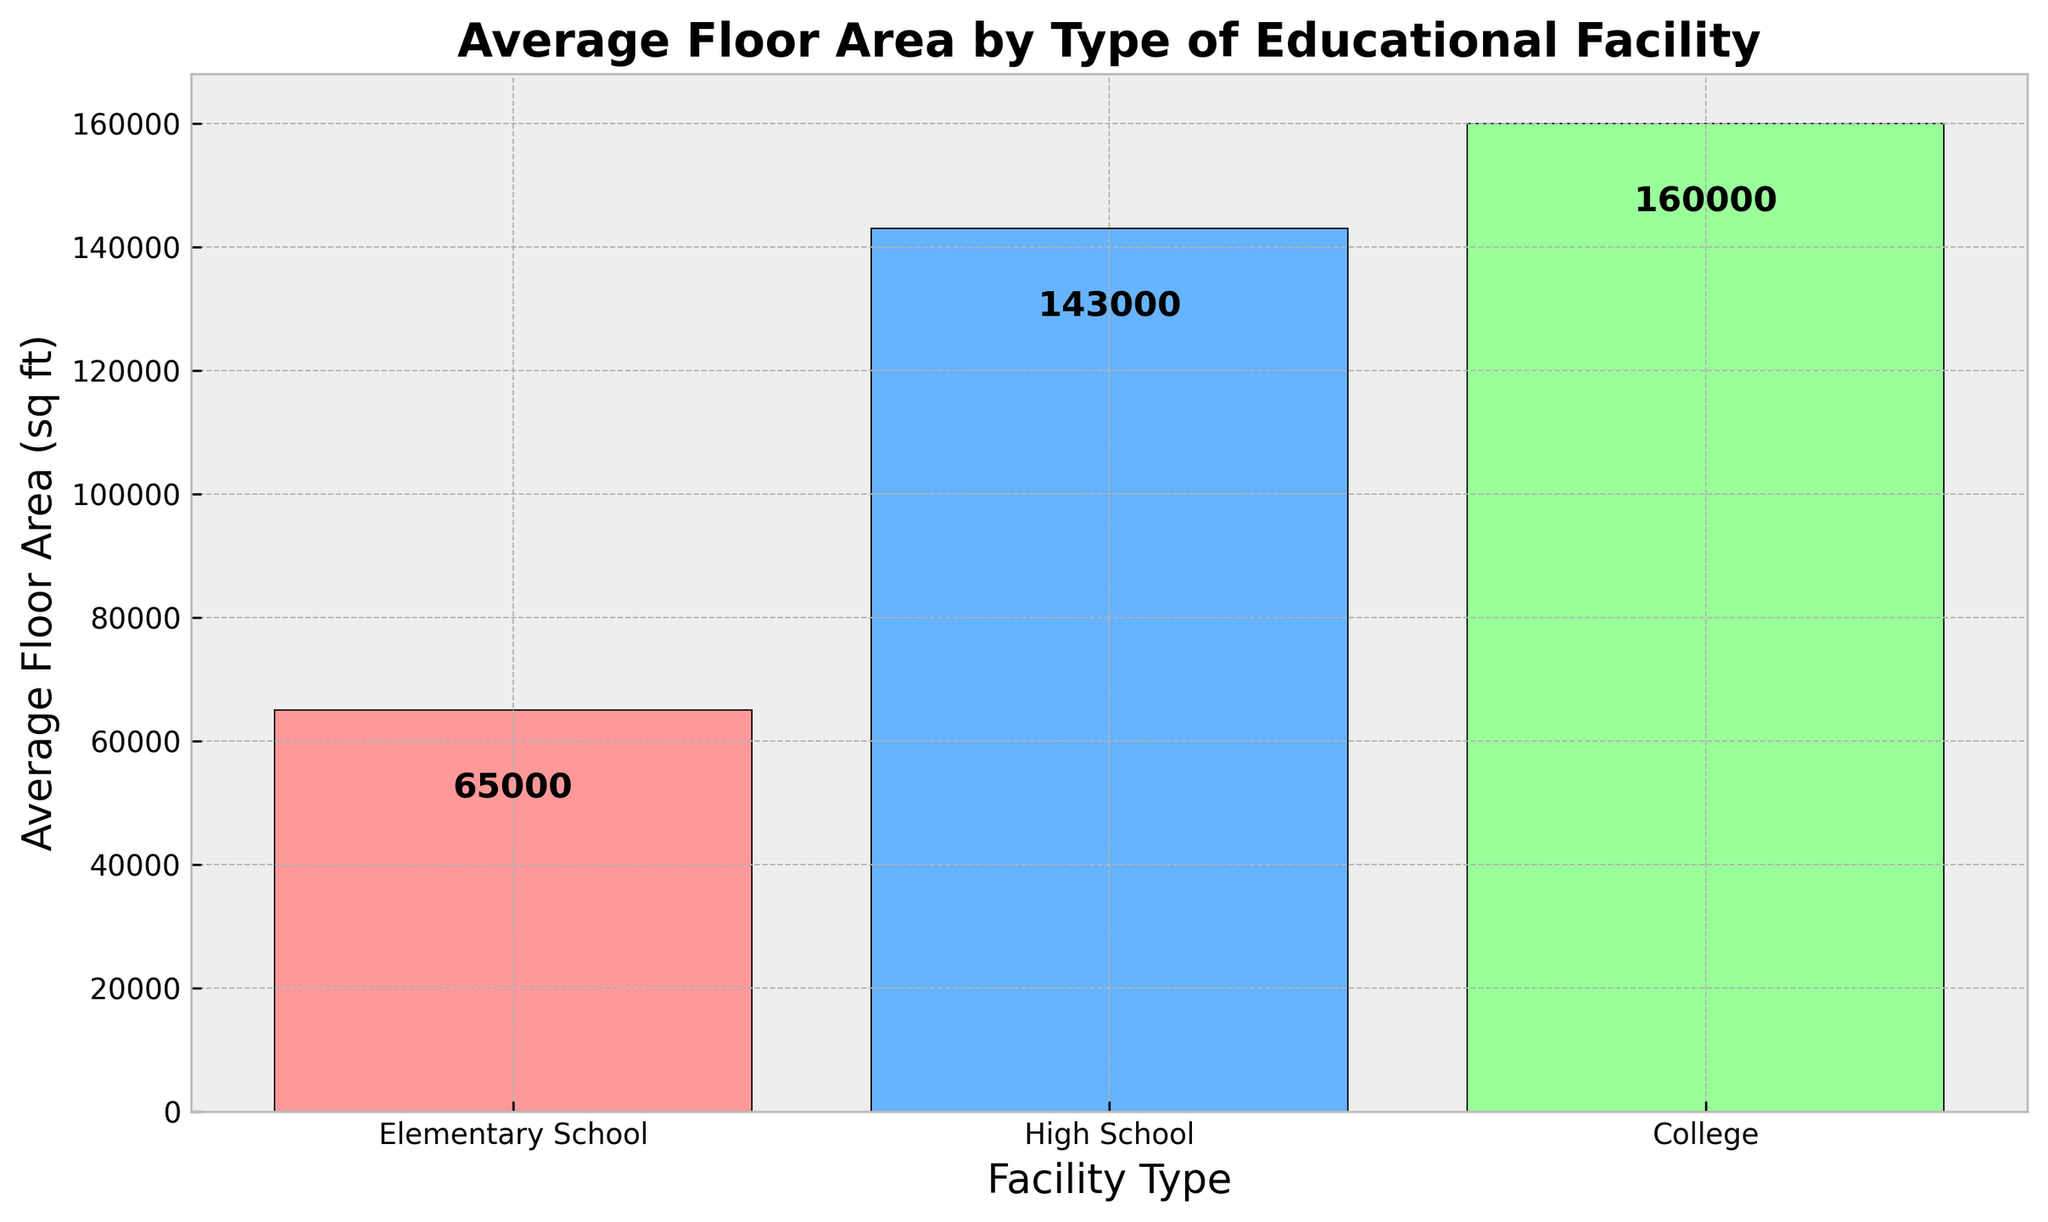Which facility type has the largest average floor area? According to the chart, among Elementary School, High School, and College, the bar representing College is the tallest, indicating that College has the largest average floor area.
Answer: College What is the difference in average floor area between High School and Elementary School? The average floor area for High School is 143,000 sq ft and for Elementary School is 65,000 sq ft. The difference is calculated as 143,000 - 65,000 = 78,000 sq ft.
Answer: 78,000 sq ft Compare the average floor area of Elementary School and College. How many times greater is the College's average floor area than the Elementary School's? The average floor area for College is 160,000 sq ft and for Elementary School is 65,000 sq ft. To find how many times greater, divide College's floor area by Elementary School's: 160,000 / 65,000 ≈ 2.46. So, the College's average floor area is approximately 2.46 times greater.
Answer: 2.46 times What is the total average floor area of all three facility types combined? Sum the average floor areas of Elementary School (65,000 sq ft), High School (143,000 sq ft), and College (160,000 sq ft): 65,000 + 143,000 + 160,000 = 368,000 sq ft.
Answer: 368,000 sq ft If we rank the facility types from the smallest to the largest average floor area, what is the order? By looking at the bar heights, the order from smallest to largest is Elementary School (65,000 sq ft), High School (143,000 sq ft), and College (160,000 sq ft).
Answer: Elementary School, High School, College What is the average floor area for an educational facility if we consider the mean of the three facilities shown? To find the mean average floor area of an educational facility, add the areas and divide by the number of facilities: (65,000 + 143,000 + 160,000) / 3 = 368,000 / 3 ≈ 122,667 sq ft.
Answer: 122,667 sq ft How much more floor area does a High School have compared to an Elementary School in percentage terms? First, find the difference in floor area: 143,000 - 65,000 = 78,000 sq ft. Then calculate the percentage increase relative to the Elementary School's floor area: (78,000 / 65,000) * 100 ≈ 120%.
Answer: 120% In terms of visual attributes, which facility type is represented by the green bar? By examining the color of the bars in the chart, the green bar corresponds to the College. Therefore, the College is represented by the green bar.
Answer: College 